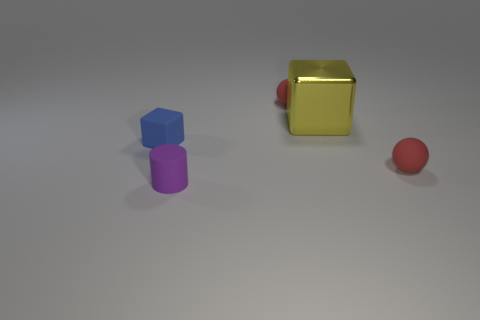What material is the yellow object that is the same shape as the small blue object?
Keep it short and to the point. Metal. Is there any other thing that has the same material as the blue thing?
Offer a terse response. Yes. What number of brown things are cylinders or tiny blocks?
Your answer should be compact. 0. There is a small sphere that is behind the blue rubber object; what material is it?
Offer a very short reply. Rubber. Is the number of small red matte balls greater than the number of small things?
Keep it short and to the point. No. There is a object that is right of the large yellow cube; is its shape the same as the blue thing?
Your answer should be compact. No. How many small matte balls are both behind the small cube and in front of the big yellow thing?
Offer a very short reply. 0. How many yellow shiny things have the same shape as the purple object?
Provide a short and direct response. 0. There is a tiny matte ball that is on the left side of the red object in front of the large shiny cube; what is its color?
Make the answer very short. Red. Do the big yellow shiny thing and the small object that is left of the purple object have the same shape?
Offer a very short reply. Yes. 